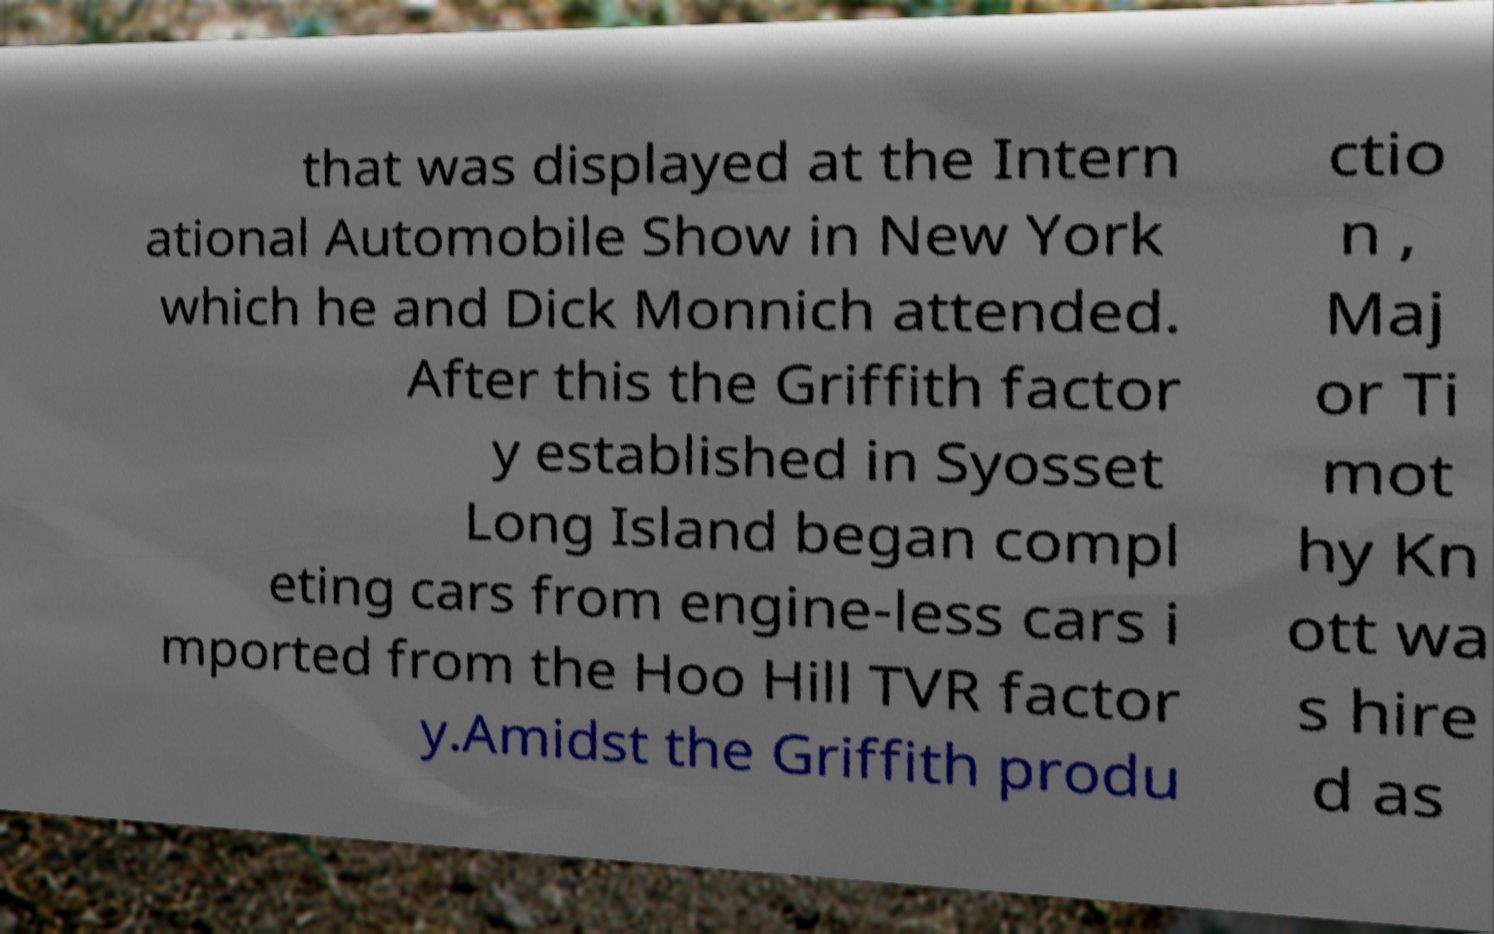Can you accurately transcribe the text from the provided image for me? that was displayed at the Intern ational Automobile Show in New York which he and Dick Monnich attended. After this the Griffith factor y established in Syosset Long Island began compl eting cars from engine-less cars i mported from the Hoo Hill TVR factor y.Amidst the Griffith produ ctio n , Maj or Ti mot hy Kn ott wa s hire d as 